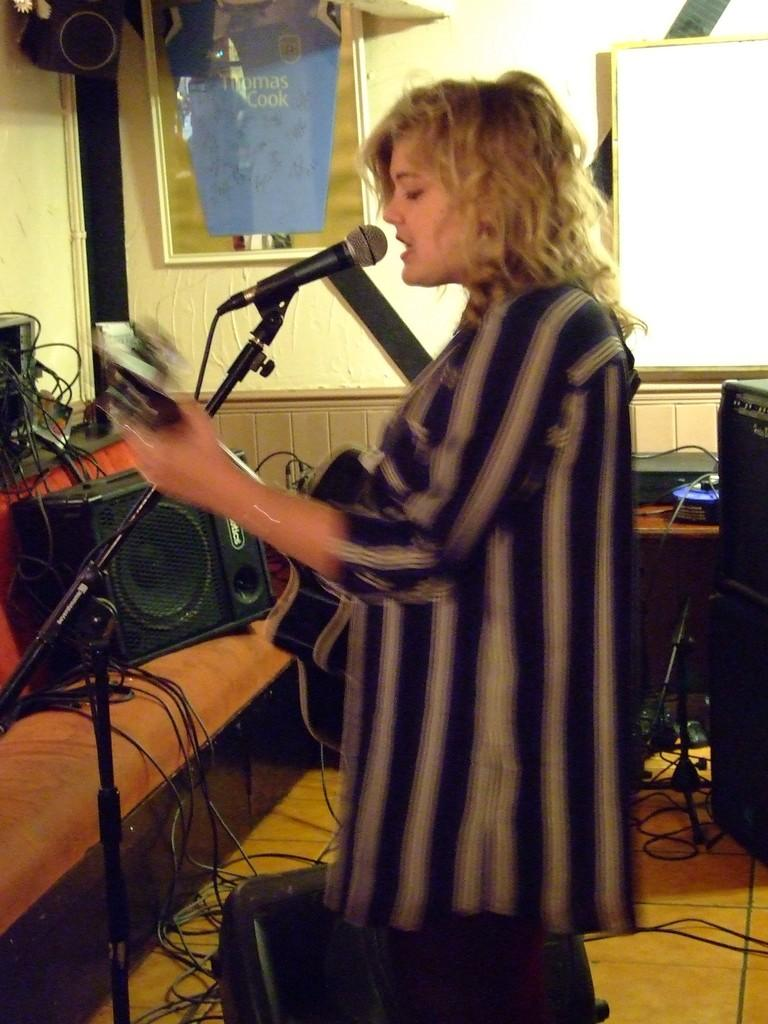Where was the image taken? The image was taken in a room. Who is present in the image? There is a woman in the image. What is the woman doing in the image? The woman is singing on a microphone. What can be seen in the background of the image? There are sound speakers, wires, and a wall in the background. What type of collar is the woman wearing in the image? There is no collar visible in the image, as the woman is not wearing any clothing. What is the woman comparing in the image? There is no comparison being made in the image; the woman is simply singing on a microphone. 